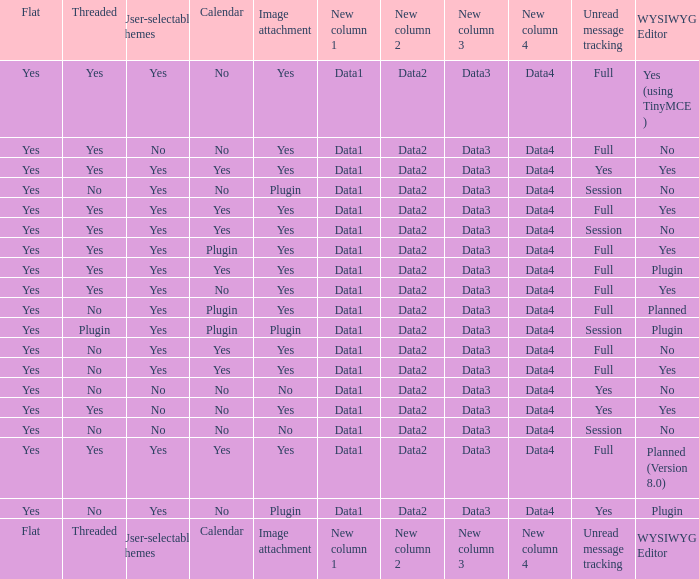Which Image attachment has a Threaded of yes, and a Calendar of yes? Yes, Yes, Yes, Yes, Yes. 